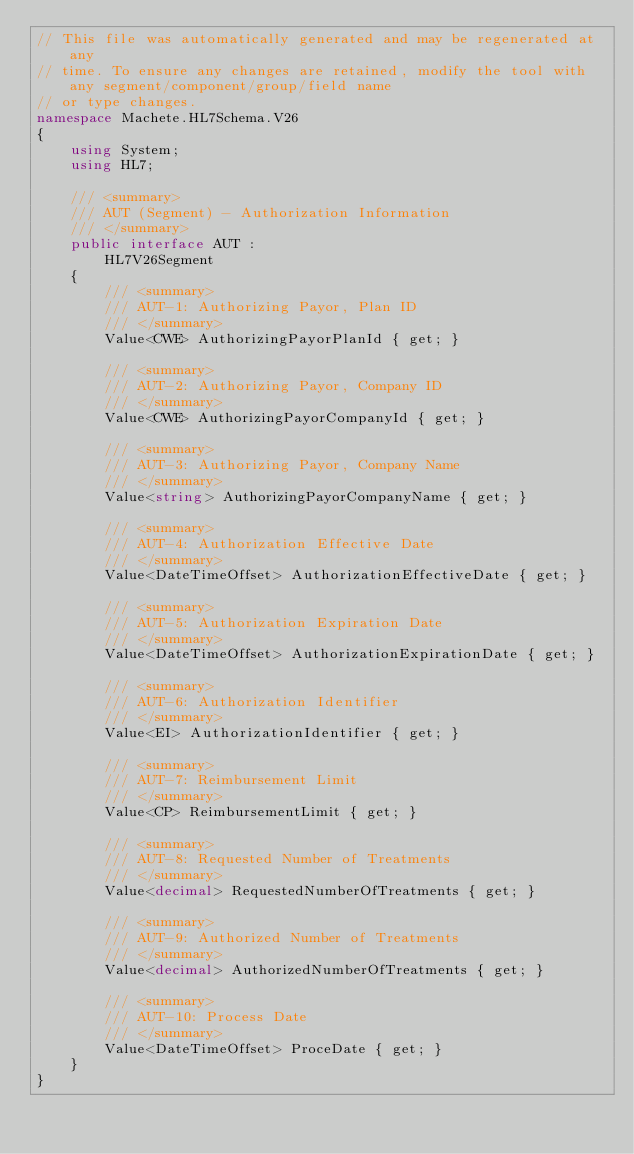Convert code to text. <code><loc_0><loc_0><loc_500><loc_500><_C#_>// This file was automatically generated and may be regenerated at any
// time. To ensure any changes are retained, modify the tool with any segment/component/group/field name
// or type changes.
namespace Machete.HL7Schema.V26
{
    using System;
    using HL7;

    /// <summary>
    /// AUT (Segment) - Authorization Information
    /// </summary>
    public interface AUT :
        HL7V26Segment
    {
        /// <summary>
        /// AUT-1: Authorizing Payor, Plan ID
        /// </summary>
        Value<CWE> AuthorizingPayorPlanId { get; }

        /// <summary>
        /// AUT-2: Authorizing Payor, Company ID
        /// </summary>
        Value<CWE> AuthorizingPayorCompanyId { get; }

        /// <summary>
        /// AUT-3: Authorizing Payor, Company Name
        /// </summary>
        Value<string> AuthorizingPayorCompanyName { get; }

        /// <summary>
        /// AUT-4: Authorization Effective Date
        /// </summary>
        Value<DateTimeOffset> AuthorizationEffectiveDate { get; }

        /// <summary>
        /// AUT-5: Authorization Expiration Date
        /// </summary>
        Value<DateTimeOffset> AuthorizationExpirationDate { get; }

        /// <summary>
        /// AUT-6: Authorization Identifier
        /// </summary>
        Value<EI> AuthorizationIdentifier { get; }

        /// <summary>
        /// AUT-7: Reimbursement Limit
        /// </summary>
        Value<CP> ReimbursementLimit { get; }

        /// <summary>
        /// AUT-8: Requested Number of Treatments
        /// </summary>
        Value<decimal> RequestedNumberOfTreatments { get; }

        /// <summary>
        /// AUT-9: Authorized Number of Treatments
        /// </summary>
        Value<decimal> AuthorizedNumberOfTreatments { get; }

        /// <summary>
        /// AUT-10: Process Date
        /// </summary>
        Value<DateTimeOffset> ProceDate { get; }
    }
}</code> 